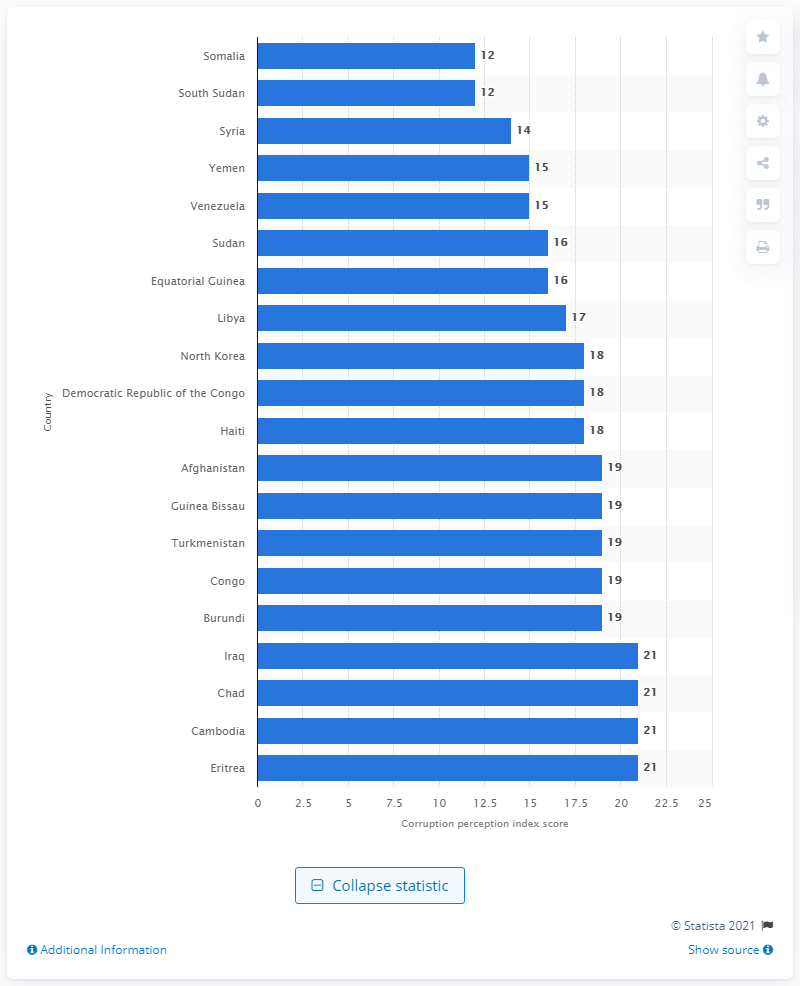Give some essential details in this illustration. According to the 2020 Corruption Perception Index, Somalia and South Sudan have a score of 12, which indicates a high level of corruption in these countries. 